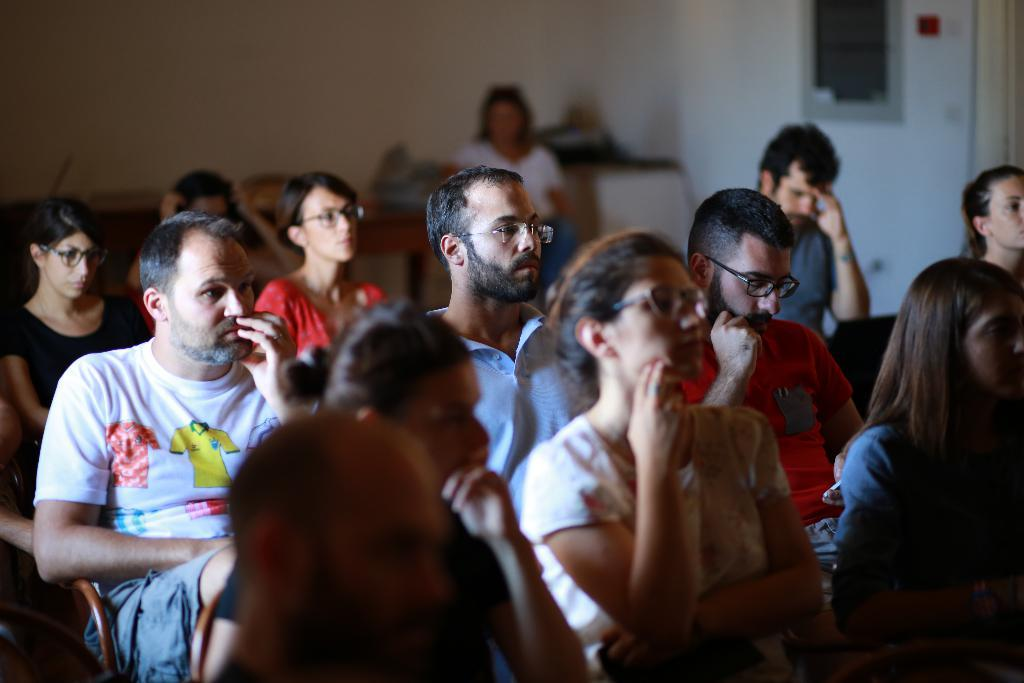What are the people in the image doing? People are sitting on chairs in a room. Can you describe any accessories that some people are wearing? Some people are wearing spectacles. What can be seen in the background of the image? There are walls in the background. How is the background of the image depicted? The background is blurred. What type of marble is being used to make bread in the image? There is no marble or bread present in the image; it features people sitting on chairs in a room with a blurred background. 